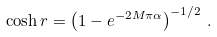<formula> <loc_0><loc_0><loc_500><loc_500>\cosh r = \left ( 1 - e ^ { - 2 M \pi \alpha } \right ) ^ { - 1 / 2 } \, .</formula> 